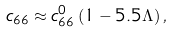Convert formula to latex. <formula><loc_0><loc_0><loc_500><loc_500>c _ { 6 6 } \approx c _ { 6 6 } ^ { 0 } \left ( 1 - 5 . 5 \Lambda \right ) ,</formula> 